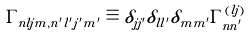<formula> <loc_0><loc_0><loc_500><loc_500>\Gamma _ { n l j m , n ^ { \prime } l ^ { \prime } j ^ { \prime } m ^ { \prime } } \equiv \delta _ { j j ^ { \prime } } \delta _ { l l ^ { \prime } } \delta _ { m m ^ { \prime } } \Gamma ^ { ( l j ) } _ { n n ^ { \prime } }</formula> 